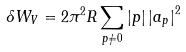<formula> <loc_0><loc_0><loc_500><loc_500>\delta W _ { V } = 2 \pi ^ { 2 } R \sum _ { p \neq 0 } | p | \left | a _ { p } \right | ^ { 2 }</formula> 